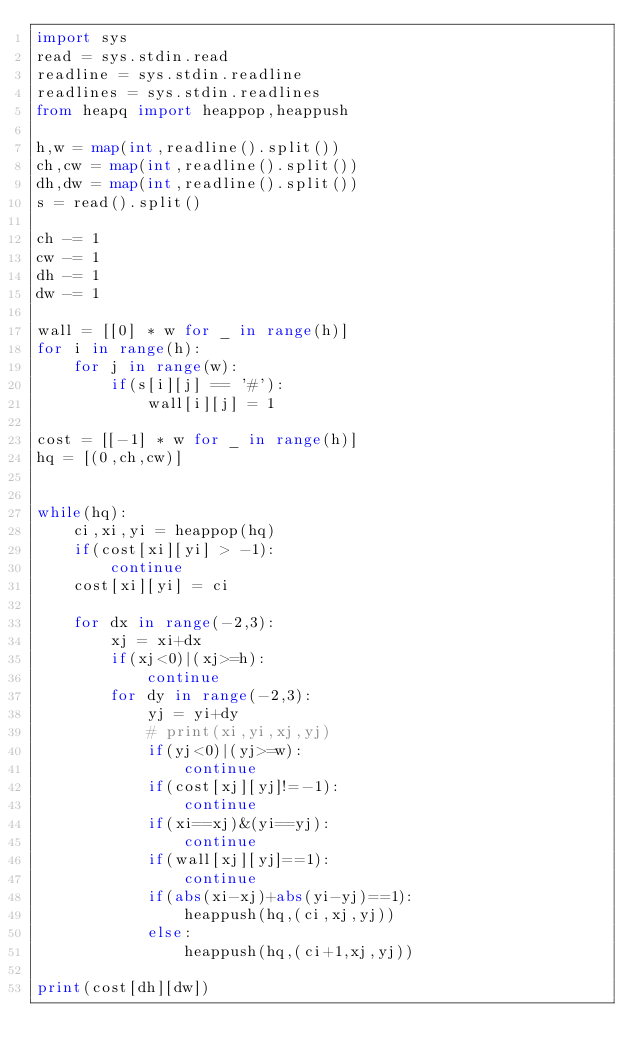<code> <loc_0><loc_0><loc_500><loc_500><_Python_>import sys
read = sys.stdin.read
readline = sys.stdin.readline
readlines = sys.stdin.readlines
from heapq import heappop,heappush

h,w = map(int,readline().split())
ch,cw = map(int,readline().split())
dh,dw = map(int,readline().split())
s = read().split()

ch -= 1
cw -= 1
dh -= 1
dw -= 1

wall = [[0] * w for _ in range(h)]
for i in range(h):
    for j in range(w):
        if(s[i][j] == '#'):
            wall[i][j] = 1

cost = [[-1] * w for _ in range(h)]
hq = [(0,ch,cw)]


while(hq):
    ci,xi,yi = heappop(hq)
    if(cost[xi][yi] > -1):
        continue
    cost[xi][yi] = ci

    for dx in range(-2,3):
        xj = xi+dx
        if(xj<0)|(xj>=h):
            continue
        for dy in range(-2,3):
            yj = yi+dy
            # print(xi,yi,xj,yj)
            if(yj<0)|(yj>=w):
                continue
            if(cost[xj][yj]!=-1):
                continue
            if(xi==xj)&(yi==yj):
                continue
            if(wall[xj][yj]==1):
                continue
            if(abs(xi-xj)+abs(yi-yj)==1):
                heappush(hq,(ci,xj,yj))
            else:
                heappush(hq,(ci+1,xj,yj))

print(cost[dh][dw])</code> 